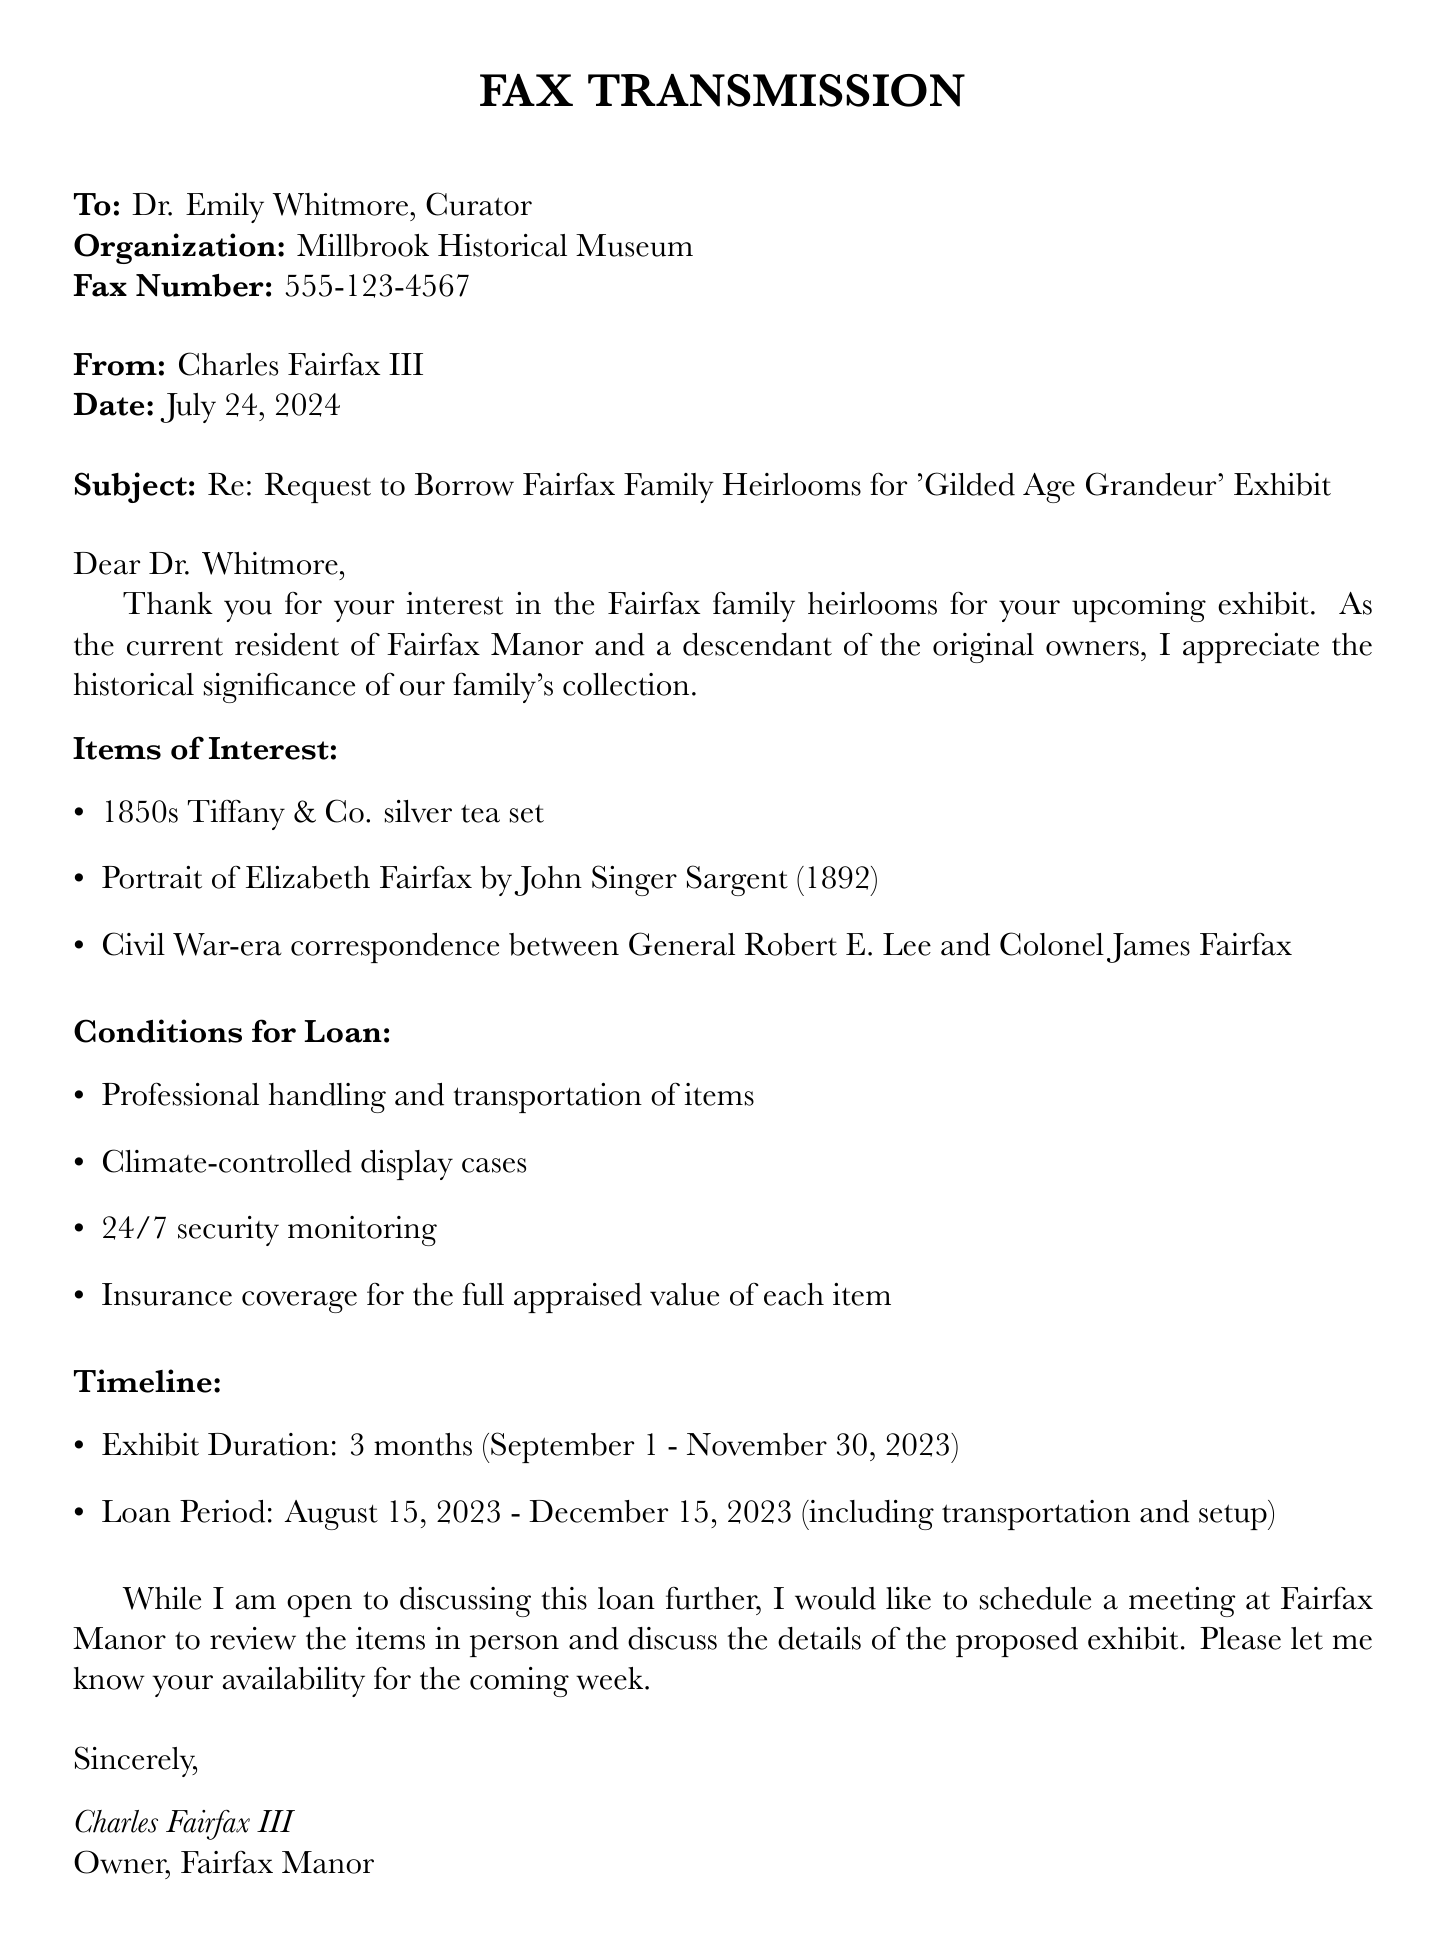what is the name of the museum requesting items? The museum's name is included in the document as the organization making the request.
Answer: Millbrook Historical Museum what is the subject of the fax? The subject line summarizes the main purpose of the fax, which is to address the request made by Dr. Whitmore.
Answer: Request to Borrow Fairfax Family Heirlooms for 'Gilded Age Grandeur' Exhibit how many months is the exhibit duration? The document specifies the duration of the exhibit in months.
Answer: 3 months what is one item listed for loan? The document provides a list of specific items that the museum is interested in borrowing from the Fairfax family collection.
Answer: 1850s Tiffany & Co. silver tea set who is the author of the fax? The writer's name is clearly stated at the end of the document, identifying himself as the owner of the manor.
Answer: Charles Fairfax III what is the start date of the loan period? The loan period's starting date is specifically mentioned in the document, setting the timeline for the loan.
Answer: August 15, 2023 what security measures are requested for the exhibit? The document includes a list of conditions that need to be met for the loan, including security measures for the items.
Answer: 24/7 security monitoring what type of display cases are required? A condition regarding the care of the items is clearly stated in the document about the display cases.
Answer: Climate-controlled display cases what is the insurance requirement mentioned? The document specifies a condition related to insurance for the items being loaned.
Answer: Insurance coverage for the full appraised value of each item 